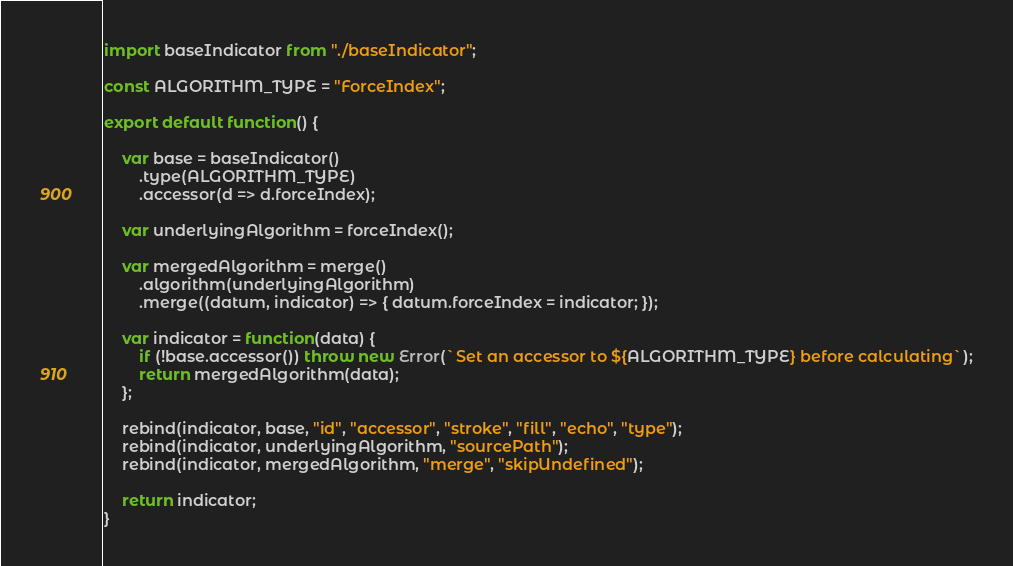Convert code to text. <code><loc_0><loc_0><loc_500><loc_500><_JavaScript_>import baseIndicator from "./baseIndicator";

const ALGORITHM_TYPE = "ForceIndex";

export default function() {

	var base = baseIndicator()
		.type(ALGORITHM_TYPE)
		.accessor(d => d.forceIndex);

	var underlyingAlgorithm = forceIndex();

	var mergedAlgorithm = merge()
		.algorithm(underlyingAlgorithm)
		.merge((datum, indicator) => { datum.forceIndex = indicator; });

	var indicator = function(data) {
		if (!base.accessor()) throw new Error(`Set an accessor to ${ALGORITHM_TYPE} before calculating`);
		return mergedAlgorithm(data);
	};

	rebind(indicator, base, "id", "accessor", "stroke", "fill", "echo", "type");
	rebind(indicator, underlyingAlgorithm, "sourcePath");
	rebind(indicator, mergedAlgorithm, "merge", "skipUndefined");

	return indicator;
}
</code> 